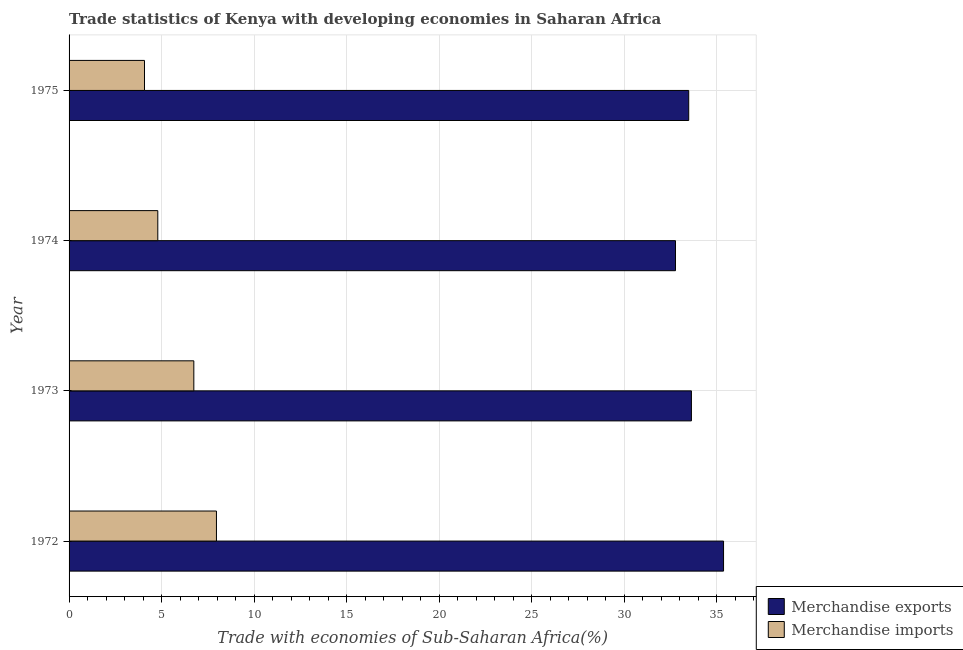How many different coloured bars are there?
Your answer should be compact. 2. How many bars are there on the 2nd tick from the top?
Offer a very short reply. 2. How many bars are there on the 3rd tick from the bottom?
Ensure brevity in your answer.  2. What is the merchandise exports in 1974?
Give a very brief answer. 32.78. Across all years, what is the maximum merchandise exports?
Your response must be concise. 35.38. Across all years, what is the minimum merchandise imports?
Offer a terse response. 4.08. In which year was the merchandise exports maximum?
Give a very brief answer. 1972. In which year was the merchandise imports minimum?
Ensure brevity in your answer.  1975. What is the total merchandise imports in the graph?
Your response must be concise. 23.58. What is the difference between the merchandise exports in 1972 and that in 1974?
Offer a very short reply. 2.6. What is the difference between the merchandise exports in 1975 and the merchandise imports in 1973?
Your response must be concise. 26.75. What is the average merchandise exports per year?
Ensure brevity in your answer.  33.82. In the year 1973, what is the difference between the merchandise exports and merchandise imports?
Offer a terse response. 26.9. What is the ratio of the merchandise imports in 1974 to that in 1975?
Ensure brevity in your answer.  1.18. What is the difference between the highest and the second highest merchandise exports?
Give a very brief answer. 1.74. What is the difference between the highest and the lowest merchandise exports?
Your answer should be very brief. 2.6. What does the 1st bar from the top in 1975 represents?
Ensure brevity in your answer.  Merchandise imports. What does the 1st bar from the bottom in 1973 represents?
Give a very brief answer. Merchandise exports. How many years are there in the graph?
Provide a short and direct response. 4. What is the difference between two consecutive major ticks on the X-axis?
Give a very brief answer. 5. Does the graph contain any zero values?
Give a very brief answer. No. Does the graph contain grids?
Your response must be concise. Yes. Where does the legend appear in the graph?
Make the answer very short. Bottom right. What is the title of the graph?
Your answer should be compact. Trade statistics of Kenya with developing economies in Saharan Africa. Does "Highest 10% of population" appear as one of the legend labels in the graph?
Your answer should be very brief. No. What is the label or title of the X-axis?
Keep it short and to the point. Trade with economies of Sub-Saharan Africa(%). What is the label or title of the Y-axis?
Your response must be concise. Year. What is the Trade with economies of Sub-Saharan Africa(%) in Merchandise exports in 1972?
Provide a succinct answer. 35.38. What is the Trade with economies of Sub-Saharan Africa(%) in Merchandise imports in 1972?
Your response must be concise. 7.97. What is the Trade with economies of Sub-Saharan Africa(%) in Merchandise exports in 1973?
Provide a short and direct response. 33.64. What is the Trade with economies of Sub-Saharan Africa(%) of Merchandise imports in 1973?
Offer a terse response. 6.74. What is the Trade with economies of Sub-Saharan Africa(%) of Merchandise exports in 1974?
Provide a succinct answer. 32.78. What is the Trade with economies of Sub-Saharan Africa(%) in Merchandise imports in 1974?
Provide a succinct answer. 4.8. What is the Trade with economies of Sub-Saharan Africa(%) in Merchandise exports in 1975?
Make the answer very short. 33.49. What is the Trade with economies of Sub-Saharan Africa(%) in Merchandise imports in 1975?
Your response must be concise. 4.08. Across all years, what is the maximum Trade with economies of Sub-Saharan Africa(%) of Merchandise exports?
Give a very brief answer. 35.38. Across all years, what is the maximum Trade with economies of Sub-Saharan Africa(%) in Merchandise imports?
Ensure brevity in your answer.  7.97. Across all years, what is the minimum Trade with economies of Sub-Saharan Africa(%) of Merchandise exports?
Offer a terse response. 32.78. Across all years, what is the minimum Trade with economies of Sub-Saharan Africa(%) in Merchandise imports?
Give a very brief answer. 4.08. What is the total Trade with economies of Sub-Saharan Africa(%) of Merchandise exports in the graph?
Your response must be concise. 135.29. What is the total Trade with economies of Sub-Saharan Africa(%) in Merchandise imports in the graph?
Provide a short and direct response. 23.58. What is the difference between the Trade with economies of Sub-Saharan Africa(%) in Merchandise exports in 1972 and that in 1973?
Offer a very short reply. 1.74. What is the difference between the Trade with economies of Sub-Saharan Africa(%) of Merchandise imports in 1972 and that in 1973?
Your answer should be compact. 1.22. What is the difference between the Trade with economies of Sub-Saharan Africa(%) of Merchandise exports in 1972 and that in 1974?
Your answer should be very brief. 2.6. What is the difference between the Trade with economies of Sub-Saharan Africa(%) in Merchandise imports in 1972 and that in 1974?
Ensure brevity in your answer.  3.17. What is the difference between the Trade with economies of Sub-Saharan Africa(%) in Merchandise exports in 1972 and that in 1975?
Give a very brief answer. 1.88. What is the difference between the Trade with economies of Sub-Saharan Africa(%) of Merchandise imports in 1972 and that in 1975?
Give a very brief answer. 3.89. What is the difference between the Trade with economies of Sub-Saharan Africa(%) in Merchandise exports in 1973 and that in 1974?
Make the answer very short. 0.86. What is the difference between the Trade with economies of Sub-Saharan Africa(%) of Merchandise imports in 1973 and that in 1974?
Ensure brevity in your answer.  1.95. What is the difference between the Trade with economies of Sub-Saharan Africa(%) of Merchandise exports in 1973 and that in 1975?
Your response must be concise. 0.15. What is the difference between the Trade with economies of Sub-Saharan Africa(%) of Merchandise imports in 1973 and that in 1975?
Your answer should be very brief. 2.67. What is the difference between the Trade with economies of Sub-Saharan Africa(%) in Merchandise exports in 1974 and that in 1975?
Your answer should be compact. -0.72. What is the difference between the Trade with economies of Sub-Saharan Africa(%) in Merchandise imports in 1974 and that in 1975?
Offer a terse response. 0.72. What is the difference between the Trade with economies of Sub-Saharan Africa(%) in Merchandise exports in 1972 and the Trade with economies of Sub-Saharan Africa(%) in Merchandise imports in 1973?
Your answer should be very brief. 28.63. What is the difference between the Trade with economies of Sub-Saharan Africa(%) of Merchandise exports in 1972 and the Trade with economies of Sub-Saharan Africa(%) of Merchandise imports in 1974?
Ensure brevity in your answer.  30.58. What is the difference between the Trade with economies of Sub-Saharan Africa(%) of Merchandise exports in 1972 and the Trade with economies of Sub-Saharan Africa(%) of Merchandise imports in 1975?
Your response must be concise. 31.3. What is the difference between the Trade with economies of Sub-Saharan Africa(%) in Merchandise exports in 1973 and the Trade with economies of Sub-Saharan Africa(%) in Merchandise imports in 1974?
Make the answer very short. 28.84. What is the difference between the Trade with economies of Sub-Saharan Africa(%) of Merchandise exports in 1973 and the Trade with economies of Sub-Saharan Africa(%) of Merchandise imports in 1975?
Make the answer very short. 29.56. What is the difference between the Trade with economies of Sub-Saharan Africa(%) in Merchandise exports in 1974 and the Trade with economies of Sub-Saharan Africa(%) in Merchandise imports in 1975?
Offer a very short reply. 28.7. What is the average Trade with economies of Sub-Saharan Africa(%) in Merchandise exports per year?
Your response must be concise. 33.82. What is the average Trade with economies of Sub-Saharan Africa(%) of Merchandise imports per year?
Provide a succinct answer. 5.9. In the year 1972, what is the difference between the Trade with economies of Sub-Saharan Africa(%) of Merchandise exports and Trade with economies of Sub-Saharan Africa(%) of Merchandise imports?
Give a very brief answer. 27.41. In the year 1973, what is the difference between the Trade with economies of Sub-Saharan Africa(%) of Merchandise exports and Trade with economies of Sub-Saharan Africa(%) of Merchandise imports?
Your response must be concise. 26.9. In the year 1974, what is the difference between the Trade with economies of Sub-Saharan Africa(%) of Merchandise exports and Trade with economies of Sub-Saharan Africa(%) of Merchandise imports?
Give a very brief answer. 27.98. In the year 1975, what is the difference between the Trade with economies of Sub-Saharan Africa(%) in Merchandise exports and Trade with economies of Sub-Saharan Africa(%) in Merchandise imports?
Offer a terse response. 29.42. What is the ratio of the Trade with economies of Sub-Saharan Africa(%) of Merchandise exports in 1972 to that in 1973?
Offer a terse response. 1.05. What is the ratio of the Trade with economies of Sub-Saharan Africa(%) in Merchandise imports in 1972 to that in 1973?
Provide a succinct answer. 1.18. What is the ratio of the Trade with economies of Sub-Saharan Africa(%) of Merchandise exports in 1972 to that in 1974?
Offer a very short reply. 1.08. What is the ratio of the Trade with economies of Sub-Saharan Africa(%) of Merchandise imports in 1972 to that in 1974?
Provide a short and direct response. 1.66. What is the ratio of the Trade with economies of Sub-Saharan Africa(%) in Merchandise exports in 1972 to that in 1975?
Ensure brevity in your answer.  1.06. What is the ratio of the Trade with economies of Sub-Saharan Africa(%) in Merchandise imports in 1972 to that in 1975?
Keep it short and to the point. 1.95. What is the ratio of the Trade with economies of Sub-Saharan Africa(%) in Merchandise exports in 1973 to that in 1974?
Provide a succinct answer. 1.03. What is the ratio of the Trade with economies of Sub-Saharan Africa(%) in Merchandise imports in 1973 to that in 1974?
Offer a terse response. 1.41. What is the ratio of the Trade with economies of Sub-Saharan Africa(%) in Merchandise exports in 1973 to that in 1975?
Offer a terse response. 1. What is the ratio of the Trade with economies of Sub-Saharan Africa(%) of Merchandise imports in 1973 to that in 1975?
Provide a succinct answer. 1.65. What is the ratio of the Trade with economies of Sub-Saharan Africa(%) in Merchandise exports in 1974 to that in 1975?
Make the answer very short. 0.98. What is the ratio of the Trade with economies of Sub-Saharan Africa(%) in Merchandise imports in 1974 to that in 1975?
Provide a succinct answer. 1.18. What is the difference between the highest and the second highest Trade with economies of Sub-Saharan Africa(%) in Merchandise exports?
Ensure brevity in your answer.  1.74. What is the difference between the highest and the second highest Trade with economies of Sub-Saharan Africa(%) of Merchandise imports?
Your response must be concise. 1.22. What is the difference between the highest and the lowest Trade with economies of Sub-Saharan Africa(%) of Merchandise exports?
Keep it short and to the point. 2.6. What is the difference between the highest and the lowest Trade with economies of Sub-Saharan Africa(%) of Merchandise imports?
Offer a terse response. 3.89. 